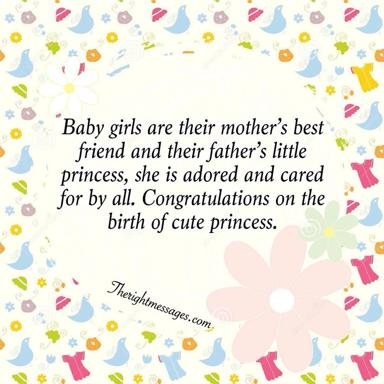How does the imagery of birds contribute to the theme of the image? The birds in the image, with their cheerful and carefree flight patterns, symbolize freedom and the limitless potential of new life. Their presence amidst the celebration of birth suggests a hope for the baby girl to soar high with possibilities and dreams, reflecting a common motif in art where birds represent aspirations and the beauty of life’s journey. 